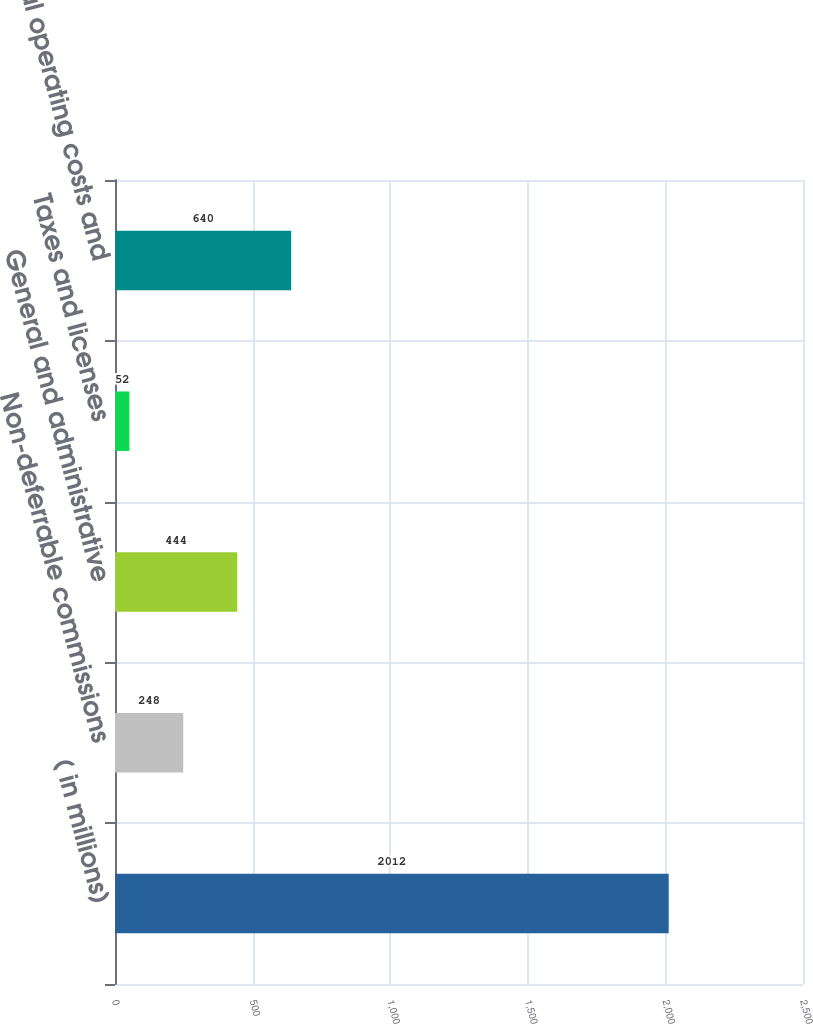<chart> <loc_0><loc_0><loc_500><loc_500><bar_chart><fcel>( in millions)<fcel>Non-deferrable commissions<fcel>General and administrative<fcel>Taxes and licenses<fcel>Total operating costs and<nl><fcel>2012<fcel>248<fcel>444<fcel>52<fcel>640<nl></chart> 